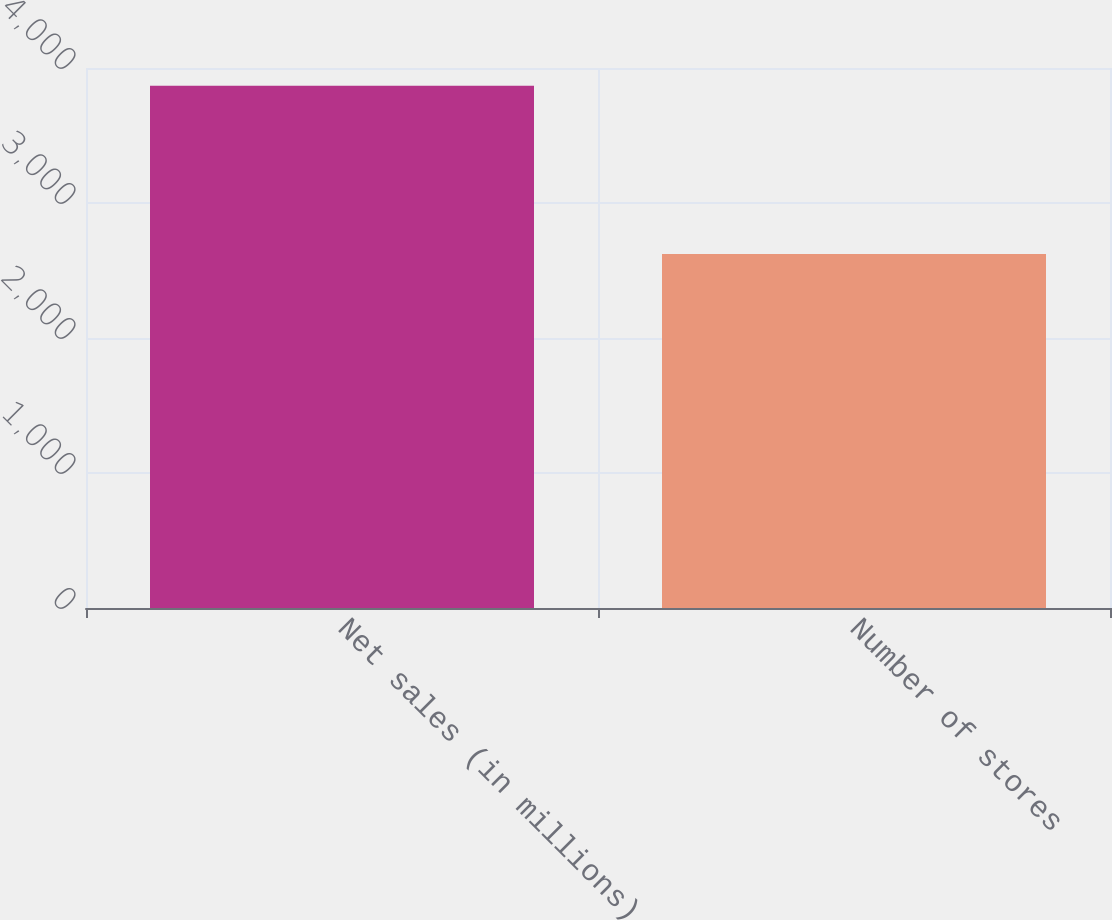<chart> <loc_0><loc_0><loc_500><loc_500><bar_chart><fcel>Net sales (in millions)<fcel>Number of stores<nl><fcel>3869.2<fcel>2622<nl></chart> 